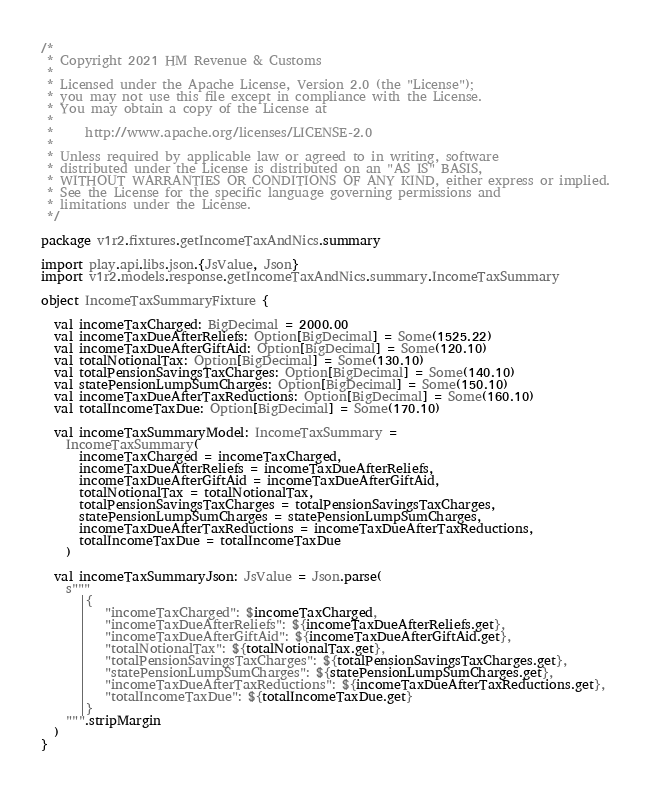<code> <loc_0><loc_0><loc_500><loc_500><_Scala_>/*
 * Copyright 2021 HM Revenue & Customs
 *
 * Licensed under the Apache License, Version 2.0 (the "License");
 * you may not use this file except in compliance with the License.
 * You may obtain a copy of the License at
 *
 *     http://www.apache.org/licenses/LICENSE-2.0
 *
 * Unless required by applicable law or agreed to in writing, software
 * distributed under the License is distributed on an "AS IS" BASIS,
 * WITHOUT WARRANTIES OR CONDITIONS OF ANY KIND, either express or implied.
 * See the License for the specific language governing permissions and
 * limitations under the License.
 */

package v1r2.fixtures.getIncomeTaxAndNics.summary

import play.api.libs.json.{JsValue, Json}
import v1r2.models.response.getIncomeTaxAndNics.summary.IncomeTaxSummary

object IncomeTaxSummaryFixture {

  val incomeTaxCharged: BigDecimal = 2000.00
  val incomeTaxDueAfterReliefs: Option[BigDecimal] = Some(1525.22)
  val incomeTaxDueAfterGiftAid: Option[BigDecimal] = Some(120.10)
  val totalNotionalTax: Option[BigDecimal] = Some(130.10)
  val totalPensionSavingsTaxCharges: Option[BigDecimal] = Some(140.10)
  val statePensionLumpSumCharges: Option[BigDecimal] = Some(150.10)
  val incomeTaxDueAfterTaxReductions: Option[BigDecimal] = Some(160.10)
  val totalIncomeTaxDue: Option[BigDecimal] = Some(170.10)

  val incomeTaxSummaryModel: IncomeTaxSummary =
    IncomeTaxSummary(
      incomeTaxCharged = incomeTaxCharged,
      incomeTaxDueAfterReliefs = incomeTaxDueAfterReliefs,
      incomeTaxDueAfterGiftAid = incomeTaxDueAfterGiftAid,
      totalNotionalTax = totalNotionalTax,
      totalPensionSavingsTaxCharges = totalPensionSavingsTaxCharges,
      statePensionLumpSumCharges = statePensionLumpSumCharges,
      incomeTaxDueAfterTaxReductions = incomeTaxDueAfterTaxReductions,
      totalIncomeTaxDue = totalIncomeTaxDue
    )

  val incomeTaxSummaryJson: JsValue = Json.parse(
    s"""
      |{
      |   "incomeTaxCharged": $incomeTaxCharged,
      |   "incomeTaxDueAfterReliefs": ${incomeTaxDueAfterReliefs.get},
      |   "incomeTaxDueAfterGiftAid": ${incomeTaxDueAfterGiftAid.get},
      |   "totalNotionalTax": ${totalNotionalTax.get},
      |   "totalPensionSavingsTaxCharges": ${totalPensionSavingsTaxCharges.get},
      |   "statePensionLumpSumCharges": ${statePensionLumpSumCharges.get},
      |   "incomeTaxDueAfterTaxReductions": ${incomeTaxDueAfterTaxReductions.get},
      |   "totalIncomeTaxDue": ${totalIncomeTaxDue.get}
      |}
    """.stripMargin
  )
}</code> 